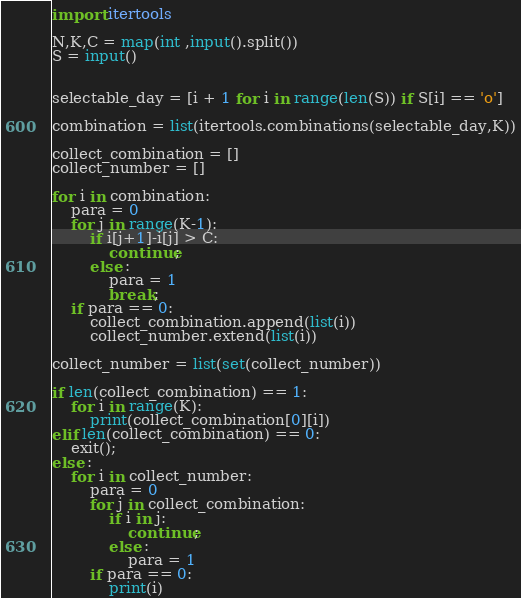<code> <loc_0><loc_0><loc_500><loc_500><_Python_>import itertools

N,K,C = map(int ,input().split())
S = input()


selectable_day = [i + 1 for i in range(len(S)) if S[i] == 'o']

combination = list(itertools.combinations(selectable_day,K))

collect_combination = []
collect_number = []

for i in combination:
    para = 0
    for j in range(K-1):
        if i[j+1]-i[j] > C:
            continue;
        else :
            para = 1
            break;
    if para == 0:
        collect_combination.append(list(i))
        collect_number.extend(list(i))

collect_number = list(set(collect_number))

if len(collect_combination) == 1:
    for i in range(K):
        print(collect_combination[0][i])
elif len(collect_combination) == 0:
    exit();
else :
    for i in collect_number:
        para = 0
        for j in collect_combination:
            if i in j:
                continue;
            else :
                para = 1
        if para == 0:
            print(i)
</code> 